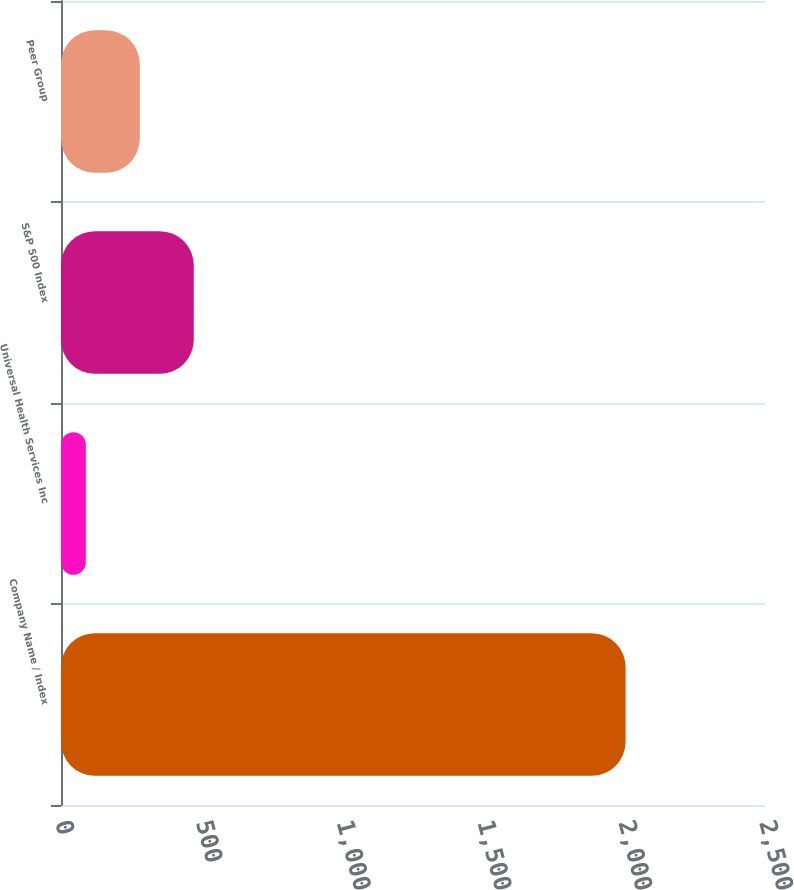Convert chart. <chart><loc_0><loc_0><loc_500><loc_500><bar_chart><fcel>Company Name / Index<fcel>Universal Health Services Inc<fcel>S&P 500 Index<fcel>Peer Group<nl><fcel>2005<fcel>88.16<fcel>471.52<fcel>279.84<nl></chart> 